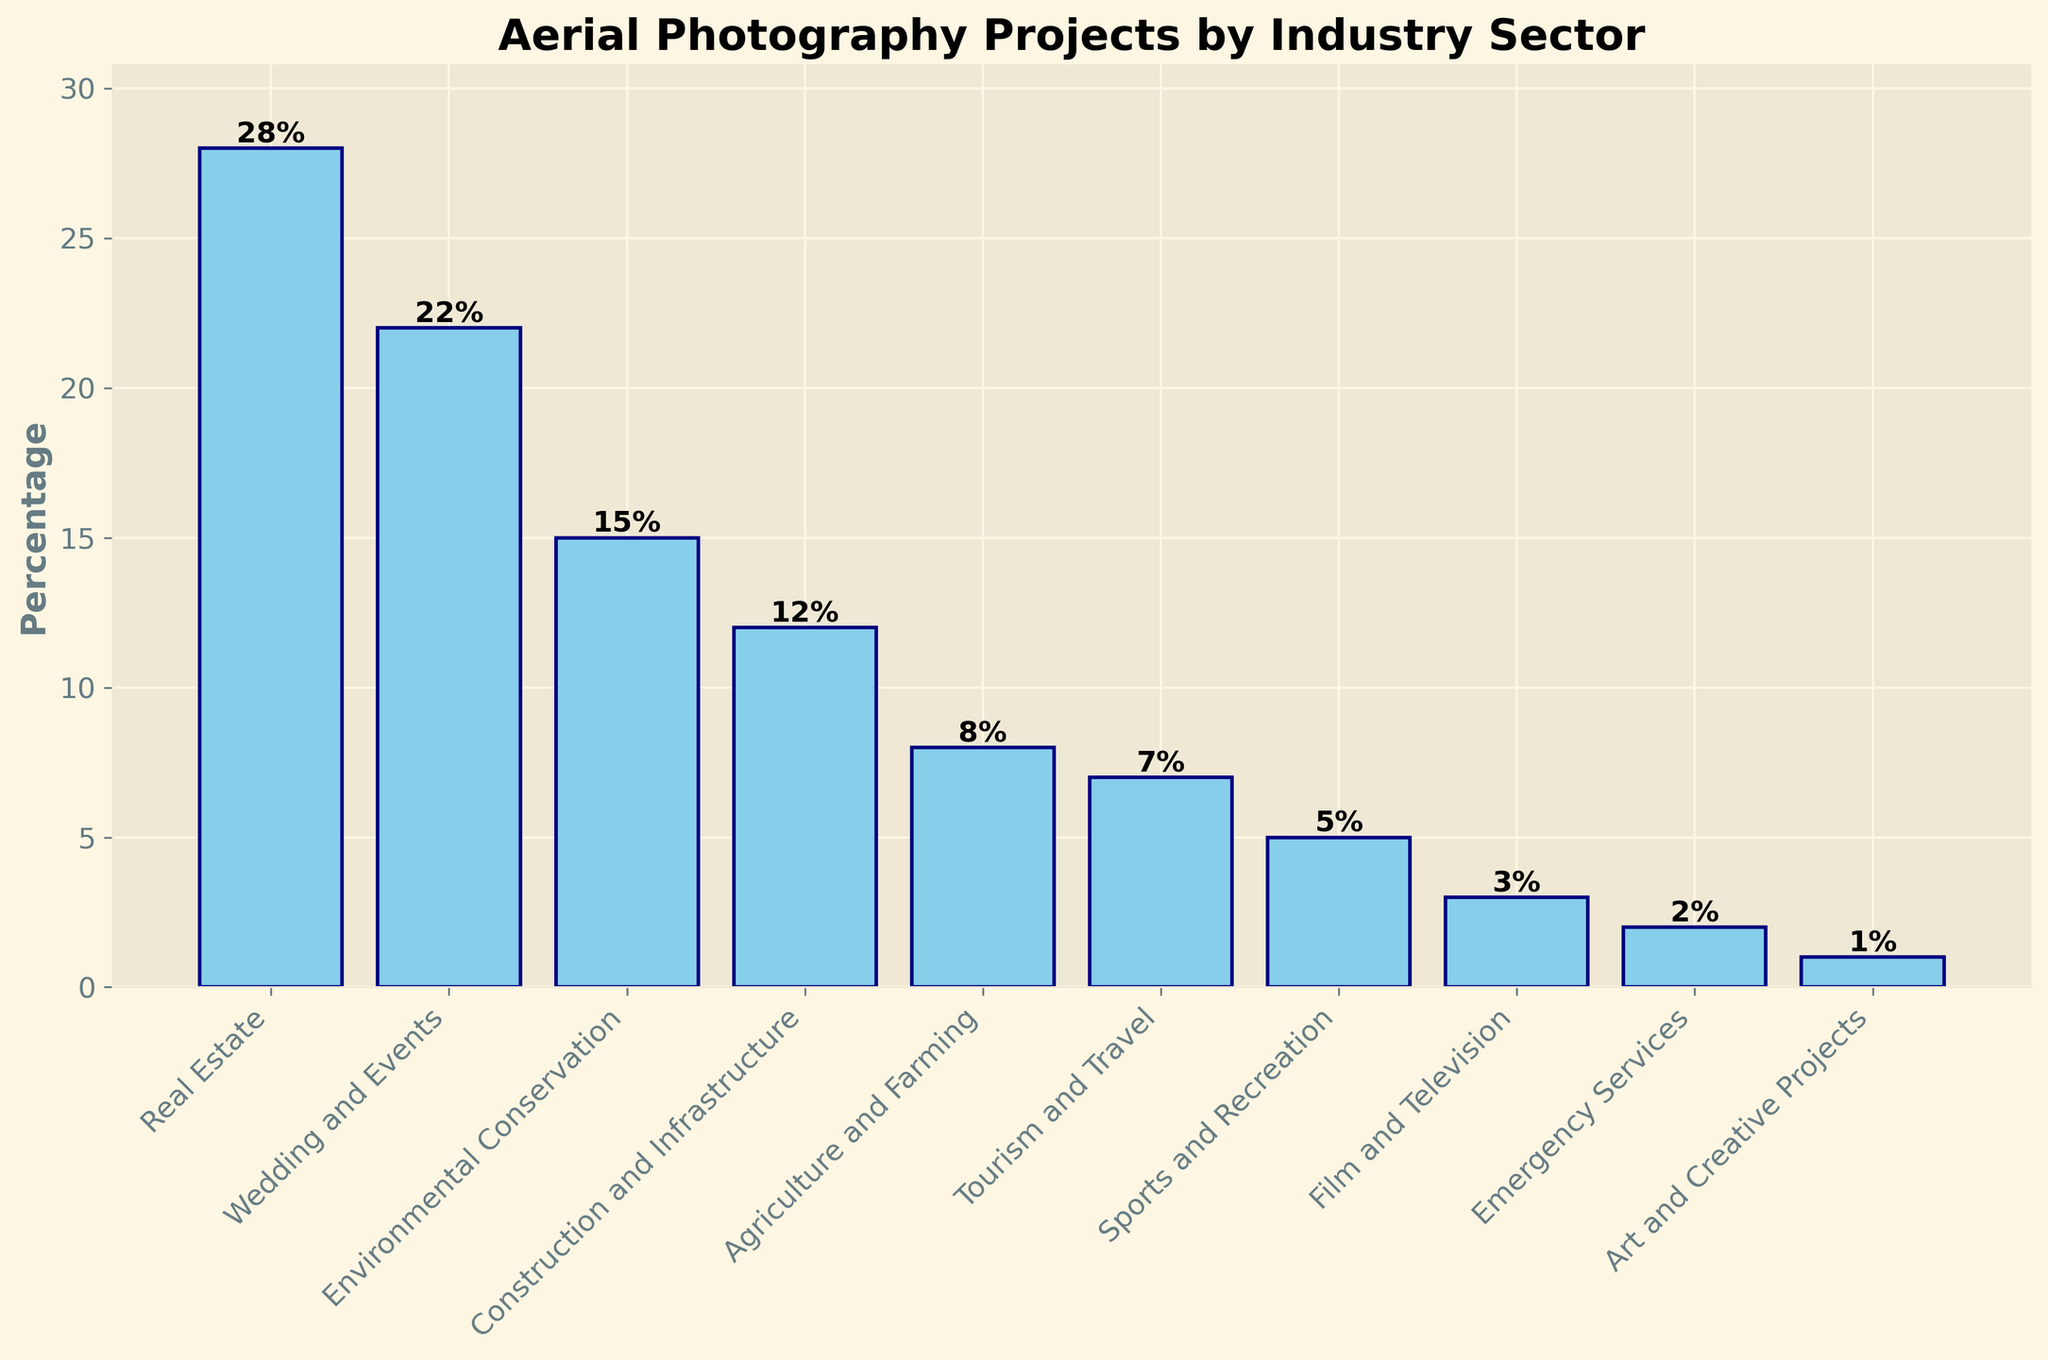Which industry sector has the highest percentage of aerial photography projects? The bar representing 'Real Estate' is the tallest among all the industry sectors, indicating it has the highest percentage of aerial photography projects.
Answer: Real Estate Which industry sector has a lower percentage of aerial photography projects, 'Events' or 'Construction and Infrastructure'? The bar for 'Construction and Infrastructure' is shorter than the bar for 'Events,' indicating a lower percentage of aerial photography projects in 'Construction and Infrastructure.'
Answer: Construction and Infrastructure What is the total percentage of aerial photography projects for 'Tourism and Travel', 'Sports and Recreation', and 'Film and Television' combined? Sum the percentages for the three sectors: Tourism and Travel (7%) + Sports and Recreation (5%) + Film and Television (3%) = 15%.
Answer: 15% Is the percentage of aerial photography projects for 'Environmental Conservation' greater than the percentage for 'Agriculture and Farming'? The bar for 'Environmental Conservation' is taller than the bar for 'Agriculture and Farming,' indicating a higher percentage for 'Environmental Conservation'.
Answer: Yes Which industry sector has the smallest percentage of aerial photography projects, and what is the percentage? The bar for 'Art and Creative Projects' is the shortest, indicating it has the smallest percentage of aerial photography projects, which is 1%.
Answer: Art and Creative Projects, 1% What is the difference in the percentage of aerial photography projects between 'Wedding and Events' and 'Environmental Conservation'? Subtract the percentage for Environmental Conservation (15%) from the percentage for Wedding and Events (22%): 22% - 15% = 7%.
Answer: 7% Rank the top three industry sectors in descending order based on the percentage of aerial photography projects. Comparing the heights of the bars, the top three sectors are: 1) Real Estate (28%), 2) Wedding and Events (22%), 3) Environmental Conservation (15%).
Answer: Real Estate, Wedding and Events, Environmental Conservation What percentage of aerial photography projects is attributed to sectors other than 'Real Estate', 'Wedding and Events', and 'Environmental Conservation'? Subtract the combined percentage of Real Estate (28%), Wedding and Events (22%), and Environmental Conservation (15%) from 100%: 100% - (28% + 22% + 15%) = 35%.
Answer: 35% How does the percentage of 'Sports and Recreation' compare to 'Emergency Services'? The bar for 'Sports and Recreation' is taller than the bar for 'Emergency Services', indicating a higher percentage for 'Sports and Recreation'.
Answer: Higher What is the average percentage of aerial photography projects for 'Agriculture and Farming', 'Tourism and Travel', and 'Emergency Services'? Sum the percentages of the three sectors: Agriculture and Farming (8%) + Tourism and Travel (7%) + Emergency Services (2%) = 17%, then divide by the number of sectors (3): 17% / 3 = 5.67%.
Answer: 5.67% 